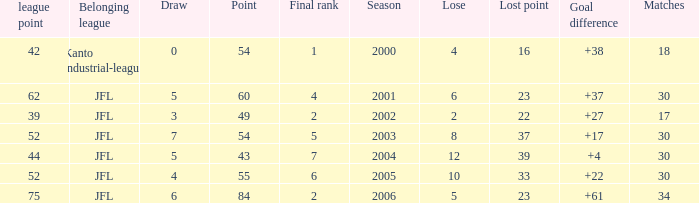I want the average lose for lost point more than 16 and goal difference less than 37 and point less than 43 None. 